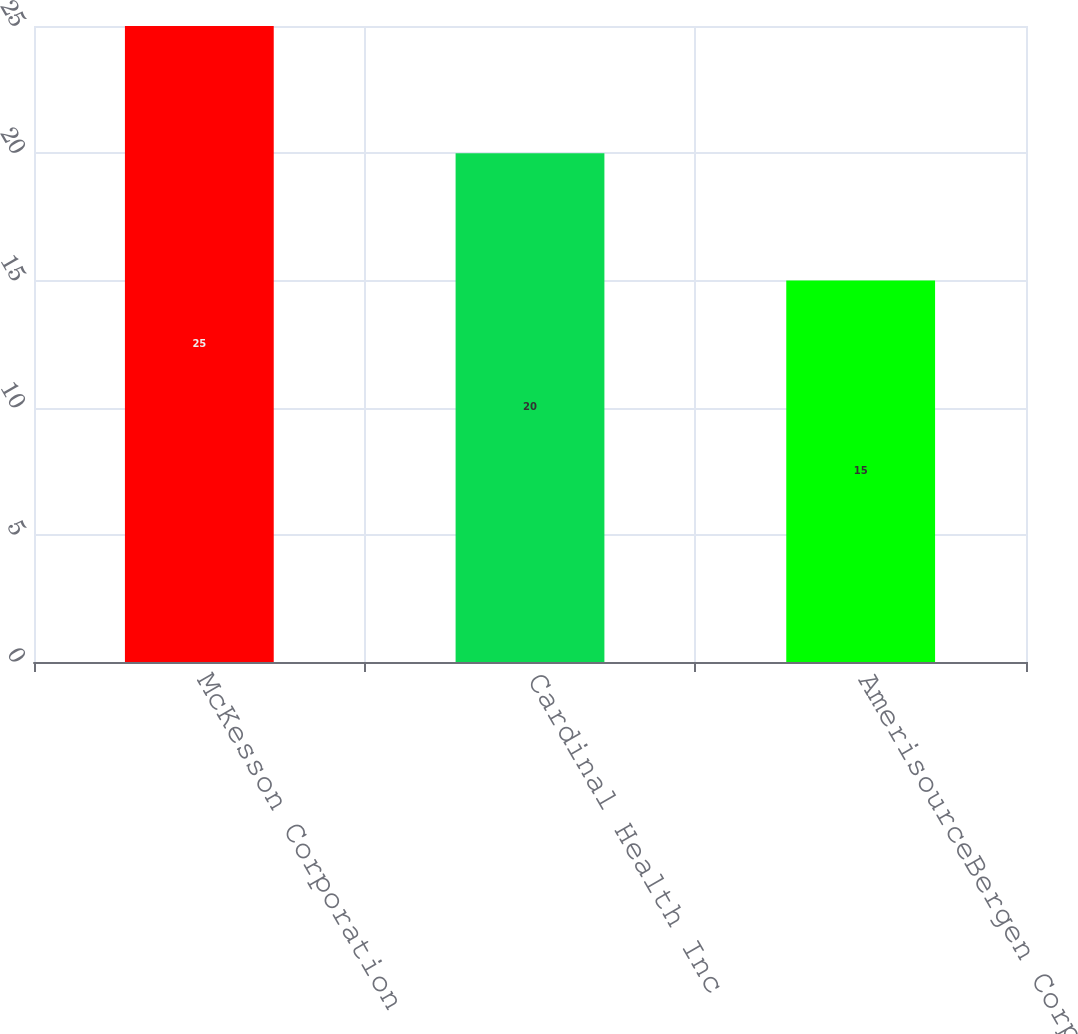<chart> <loc_0><loc_0><loc_500><loc_500><bar_chart><fcel>McKesson Corporation<fcel>Cardinal Health Inc<fcel>AmerisourceBergen Corporation<nl><fcel>25<fcel>20<fcel>15<nl></chart> 